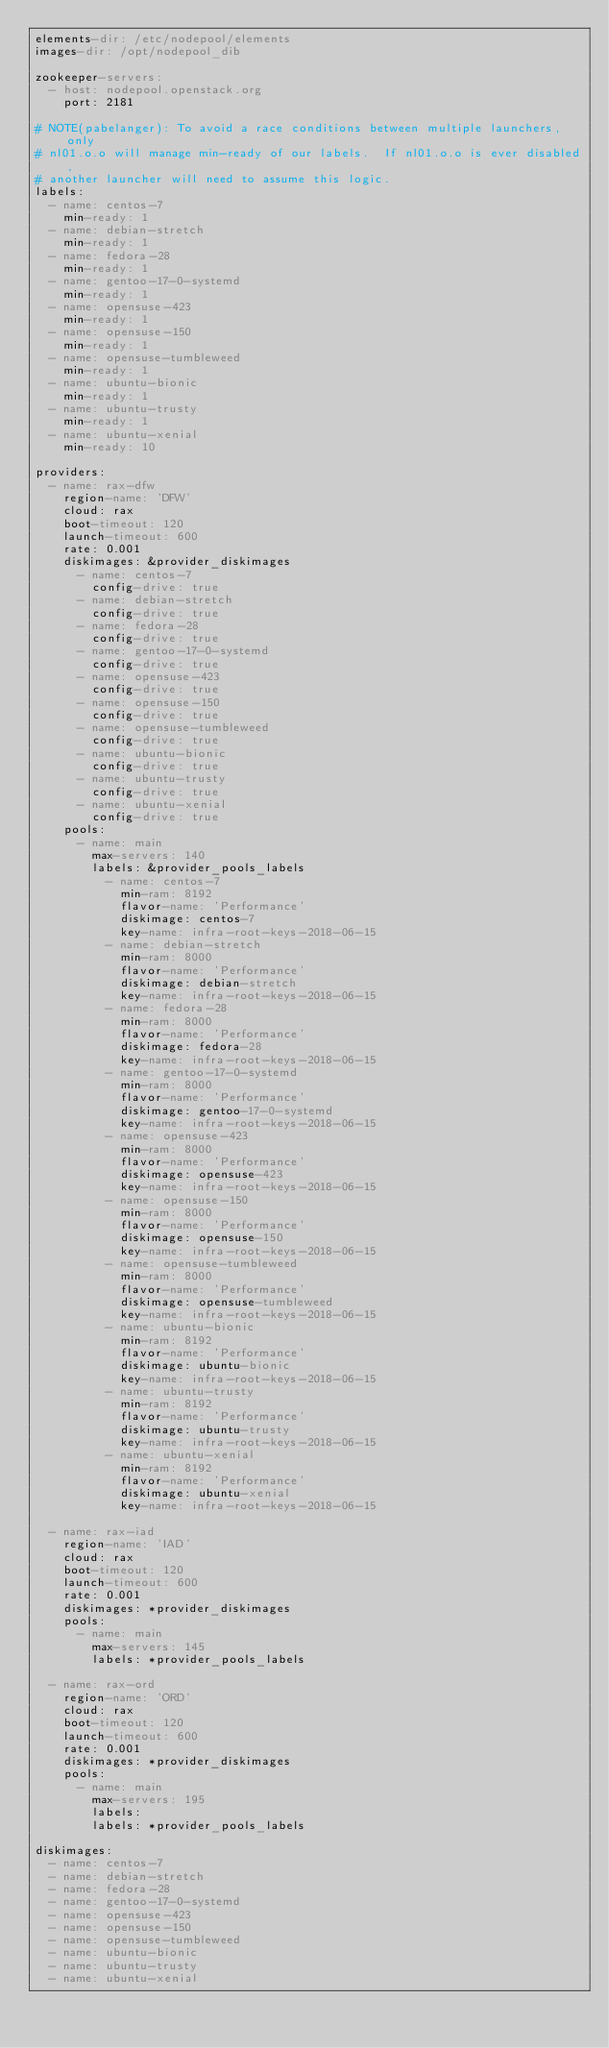<code> <loc_0><loc_0><loc_500><loc_500><_YAML_>elements-dir: /etc/nodepool/elements
images-dir: /opt/nodepool_dib

zookeeper-servers:
  - host: nodepool.openstack.org
    port: 2181

# NOTE(pabelanger): To avoid a race conditions between multiple launchers, only
# nl01.o.o will manage min-ready of our labels.  If nl01.o.o is ever disabled,
# another launcher will need to assume this logic.
labels:
  - name: centos-7
    min-ready: 1
  - name: debian-stretch
    min-ready: 1
  - name: fedora-28
    min-ready: 1
  - name: gentoo-17-0-systemd
    min-ready: 1
  - name: opensuse-423
    min-ready: 1
  - name: opensuse-150
    min-ready: 1
  - name: opensuse-tumbleweed
    min-ready: 1
  - name: ubuntu-bionic
    min-ready: 1
  - name: ubuntu-trusty
    min-ready: 1
  - name: ubuntu-xenial
    min-ready: 10

providers:
  - name: rax-dfw
    region-name: 'DFW'
    cloud: rax
    boot-timeout: 120
    launch-timeout: 600
    rate: 0.001
    diskimages: &provider_diskimages
      - name: centos-7
        config-drive: true
      - name: debian-stretch
        config-drive: true
      - name: fedora-28
        config-drive: true
      - name: gentoo-17-0-systemd
        config-drive: true
      - name: opensuse-423
        config-drive: true
      - name: opensuse-150
        config-drive: true
      - name: opensuse-tumbleweed
        config-drive: true
      - name: ubuntu-bionic
        config-drive: true
      - name: ubuntu-trusty
        config-drive: true
      - name: ubuntu-xenial
        config-drive: true
    pools:
      - name: main
        max-servers: 140
        labels: &provider_pools_labels
          - name: centos-7
            min-ram: 8192
            flavor-name: 'Performance'
            diskimage: centos-7
            key-name: infra-root-keys-2018-06-15
          - name: debian-stretch
            min-ram: 8000
            flavor-name: 'Performance'
            diskimage: debian-stretch
            key-name: infra-root-keys-2018-06-15
          - name: fedora-28
            min-ram: 8000
            flavor-name: 'Performance'
            diskimage: fedora-28
            key-name: infra-root-keys-2018-06-15
          - name: gentoo-17-0-systemd
            min-ram: 8000
            flavor-name: 'Performance'
            diskimage: gentoo-17-0-systemd
            key-name: infra-root-keys-2018-06-15
          - name: opensuse-423
            min-ram: 8000
            flavor-name: 'Performance'
            diskimage: opensuse-423
            key-name: infra-root-keys-2018-06-15
          - name: opensuse-150
            min-ram: 8000
            flavor-name: 'Performance'
            diskimage: opensuse-150
            key-name: infra-root-keys-2018-06-15
          - name: opensuse-tumbleweed
            min-ram: 8000
            flavor-name: 'Performance'
            diskimage: opensuse-tumbleweed
            key-name: infra-root-keys-2018-06-15
          - name: ubuntu-bionic
            min-ram: 8192
            flavor-name: 'Performance'
            diskimage: ubuntu-bionic
            key-name: infra-root-keys-2018-06-15
          - name: ubuntu-trusty
            min-ram: 8192
            flavor-name: 'Performance'
            diskimage: ubuntu-trusty
            key-name: infra-root-keys-2018-06-15
          - name: ubuntu-xenial
            min-ram: 8192
            flavor-name: 'Performance'
            diskimage: ubuntu-xenial
            key-name: infra-root-keys-2018-06-15

  - name: rax-iad
    region-name: 'IAD'
    cloud: rax
    boot-timeout: 120
    launch-timeout: 600
    rate: 0.001
    diskimages: *provider_diskimages
    pools:
      - name: main
        max-servers: 145
        labels: *provider_pools_labels

  - name: rax-ord
    region-name: 'ORD'
    cloud: rax
    boot-timeout: 120
    launch-timeout: 600
    rate: 0.001
    diskimages: *provider_diskimages
    pools:
      - name: main
        max-servers: 195
        labels:
        labels: *provider_pools_labels

diskimages:
  - name: centos-7
  - name: debian-stretch
  - name: fedora-28
  - name: gentoo-17-0-systemd
  - name: opensuse-423
  - name: opensuse-150
  - name: opensuse-tumbleweed
  - name: ubuntu-bionic
  - name: ubuntu-trusty
  - name: ubuntu-xenial
</code> 